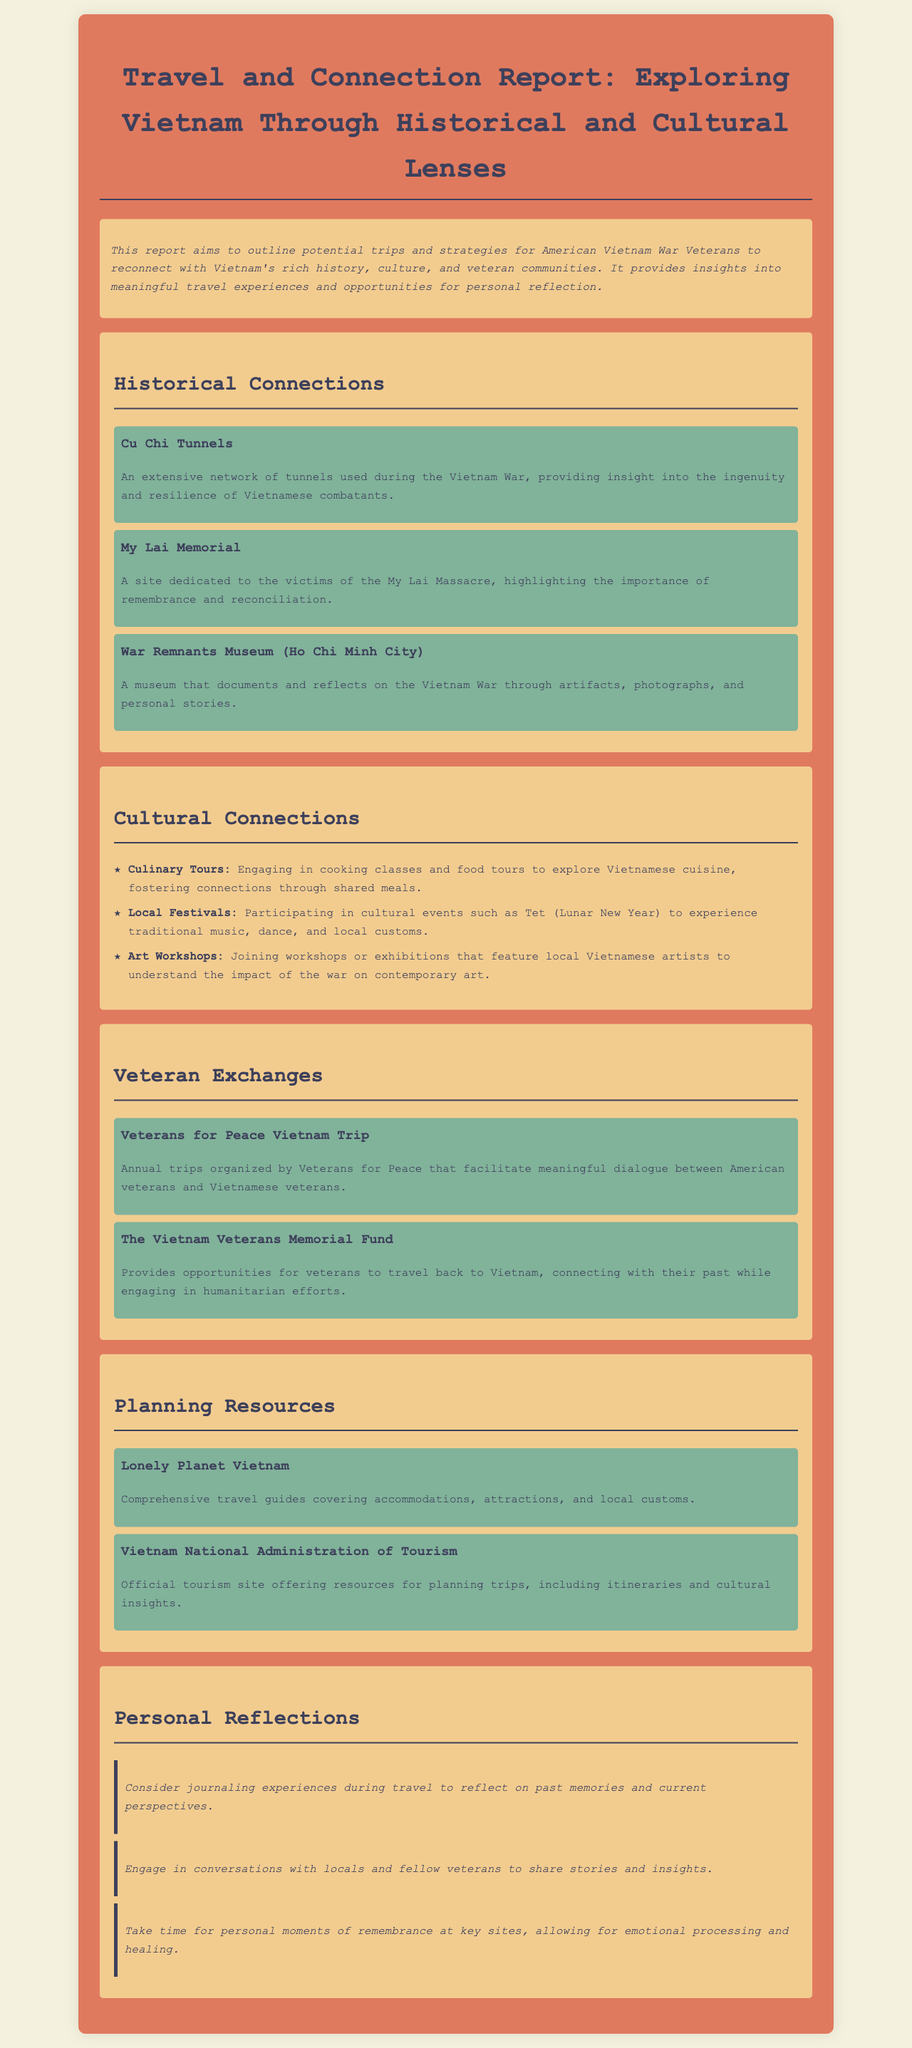What is the title of the report? The title of the report is the main heading and provides a summary of the document's focus.
Answer: Travel and Connection Report: Exploring Vietnam Through Historical and Cultural Lenses How many cultural connection activities are listed? The document outlines three cultural connection activities aimed at fostering engagement with Vietnamese culture.
Answer: Three What is one site dedicated to the My Lai Massacre? The document mentions this site under Historical Connections, highlighting its significance for remembrance.
Answer: My Lai Memorial What organization organizes annual trips for veterans? The document specifies the organization that facilitates dialogue between American and Vietnamese veterans through organized trips.
Answer: Veterans for Peace What is the resource for comprehensive travel guides? The document provides references to resources that can help with travel planning, including this specific travel guide resource.
Answer: Lonely Planet Vietnam What type of workshops can veterans join in Vietnam? The report describes one way for veterans to connect with Vietnamese artists, offering a hands-on experience.
Answer: Art Workshops What is recommended for personal reflection during travel? The document suggests a way to capture experiences and emotions while revisiting important sites and cultures.
Answer: Journaling experiences How many personal reflection activities are mentioned? The report highlights three reflective activities aimed at encouraging personal growth through travel.
Answer: Three What museum reflects on personal stories and artifacts from the Vietnam War? The report identifies this specific museum that serves to document and share experiences from the war.
Answer: War Remnants Museum (Ho Chi Minh City) 